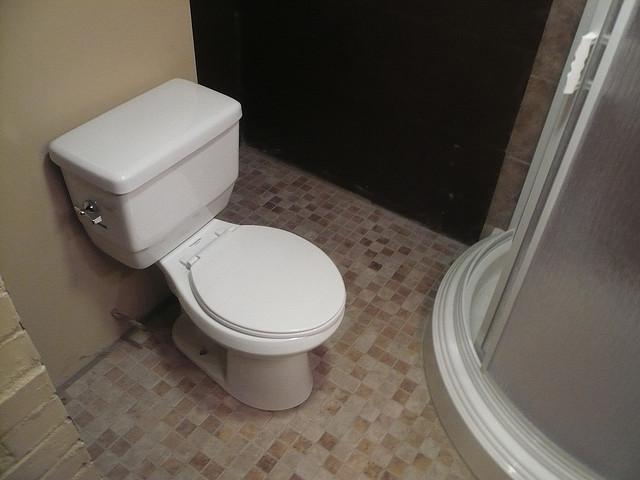How many of the cows in this picture are chocolate brown?
Give a very brief answer. 0. 